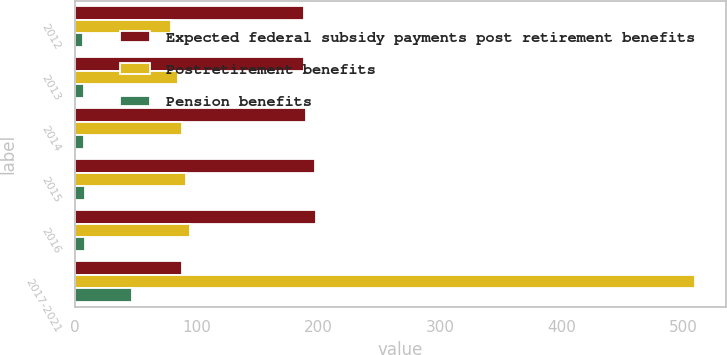Convert chart to OTSL. <chart><loc_0><loc_0><loc_500><loc_500><stacked_bar_chart><ecel><fcel>2012<fcel>2013<fcel>2014<fcel>2015<fcel>2016<fcel>2017-2021<nl><fcel>Expected federal subsidy payments post retirement benefits<fcel>188<fcel>188<fcel>190<fcel>197<fcel>198<fcel>88<nl><fcel>Postretirement benefits<fcel>79<fcel>84<fcel>88<fcel>91<fcel>94<fcel>509<nl><fcel>Pension benefits<fcel>6<fcel>7<fcel>7<fcel>8<fcel>8<fcel>47<nl></chart> 